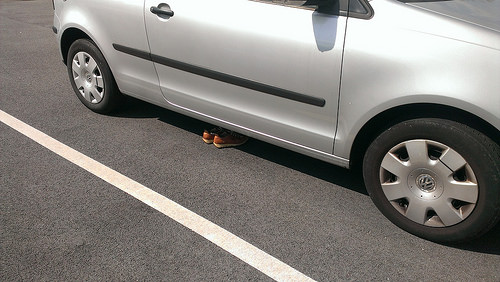<image>
Can you confirm if the shoes is on the car? No. The shoes is not positioned on the car. They may be near each other, but the shoes is not supported by or resting on top of the car. 